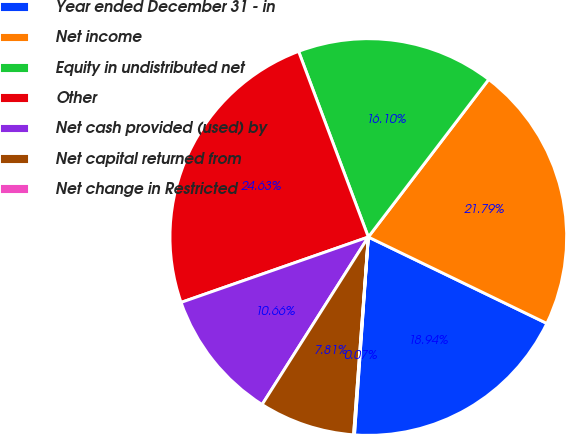<chart> <loc_0><loc_0><loc_500><loc_500><pie_chart><fcel>Year ended December 31 - in<fcel>Net income<fcel>Equity in undistributed net<fcel>Other<fcel>Net cash provided (used) by<fcel>Net capital returned from<fcel>Net change in Restricted<nl><fcel>18.94%<fcel>21.79%<fcel>16.1%<fcel>24.63%<fcel>10.66%<fcel>7.81%<fcel>0.07%<nl></chart> 